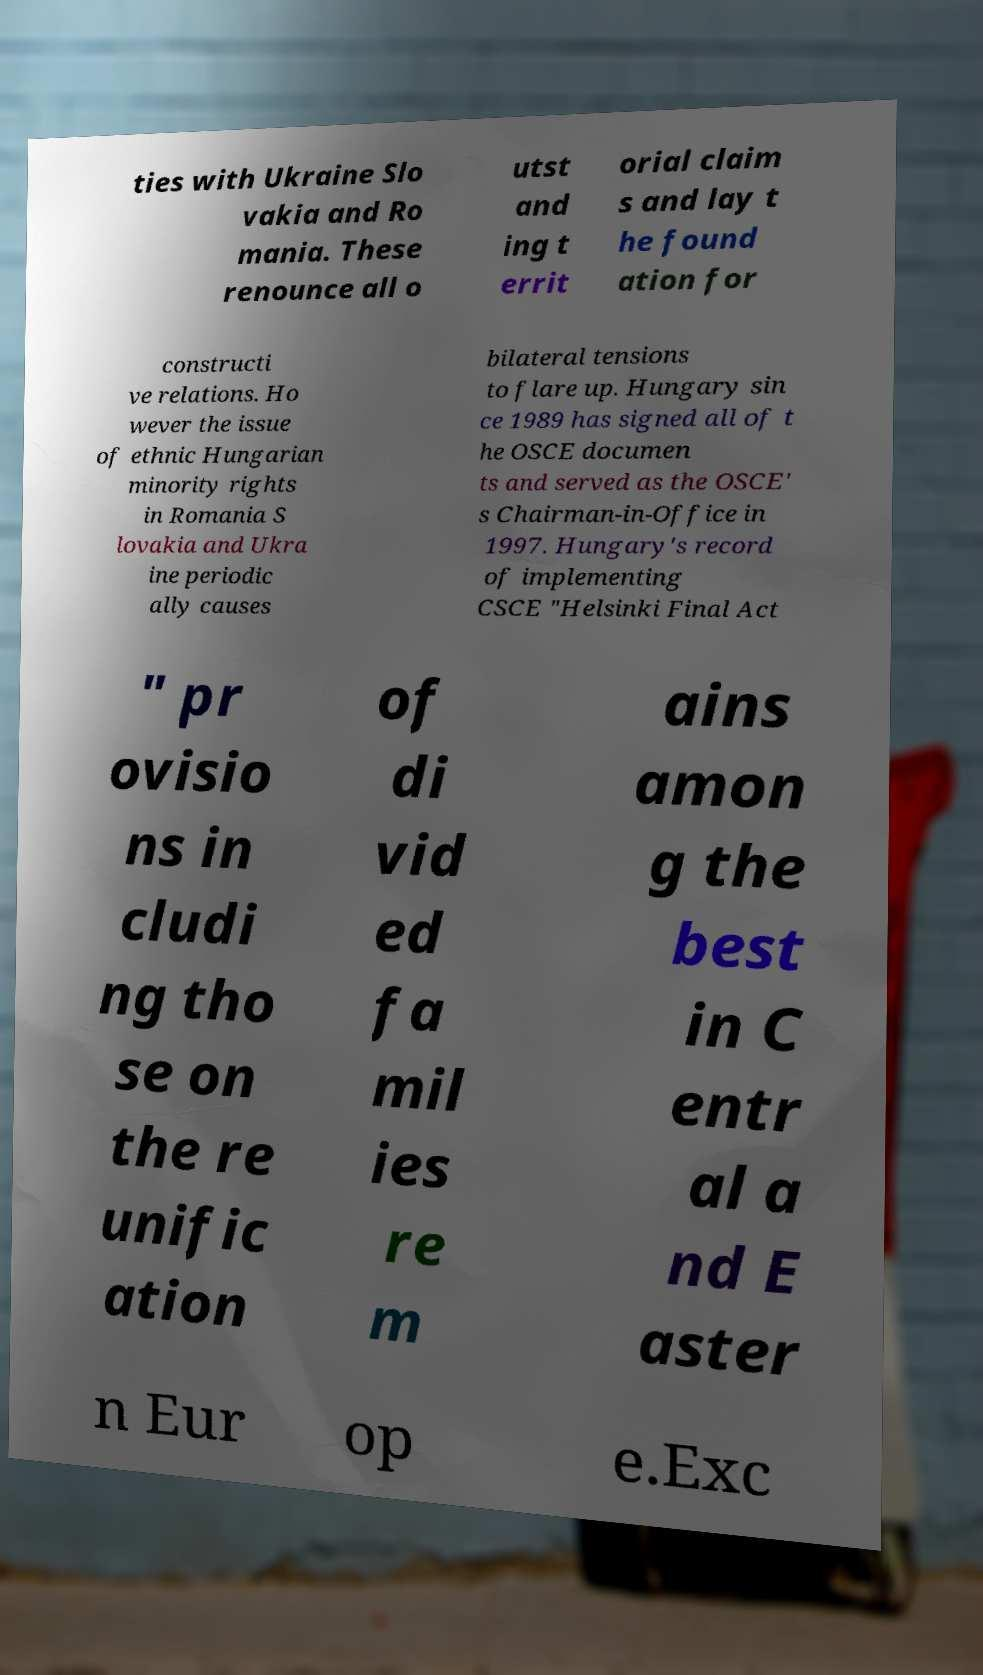I need the written content from this picture converted into text. Can you do that? ties with Ukraine Slo vakia and Ro mania. These renounce all o utst and ing t errit orial claim s and lay t he found ation for constructi ve relations. Ho wever the issue of ethnic Hungarian minority rights in Romania S lovakia and Ukra ine periodic ally causes bilateral tensions to flare up. Hungary sin ce 1989 has signed all of t he OSCE documen ts and served as the OSCE' s Chairman-in-Office in 1997. Hungary's record of implementing CSCE "Helsinki Final Act " pr ovisio ns in cludi ng tho se on the re unific ation of di vid ed fa mil ies re m ains amon g the best in C entr al a nd E aster n Eur op e.Exc 